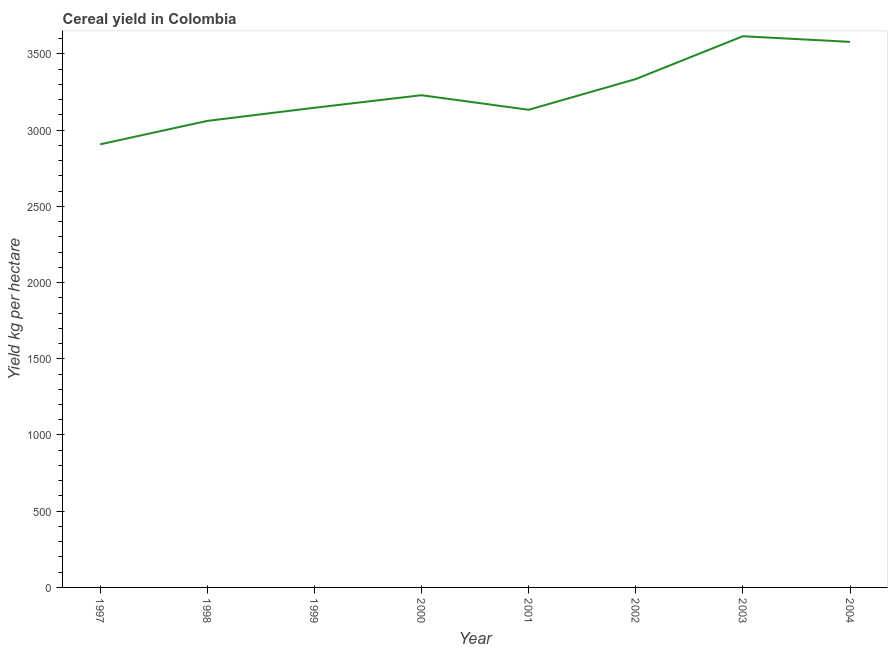What is the cereal yield in 1997?
Give a very brief answer. 2906.72. Across all years, what is the maximum cereal yield?
Your answer should be very brief. 3615.99. Across all years, what is the minimum cereal yield?
Your response must be concise. 2906.72. What is the sum of the cereal yield?
Provide a succinct answer. 2.60e+04. What is the difference between the cereal yield in 2000 and 2003?
Offer a terse response. -386.91. What is the average cereal yield per year?
Your answer should be compact. 3250.8. What is the median cereal yield?
Your response must be concise. 3187.87. In how many years, is the cereal yield greater than 700 kg per hectare?
Ensure brevity in your answer.  8. What is the ratio of the cereal yield in 2002 to that in 2004?
Provide a short and direct response. 0.93. Is the cereal yield in 1998 less than that in 2003?
Offer a very short reply. Yes. Is the difference between the cereal yield in 2000 and 2003 greater than the difference between any two years?
Ensure brevity in your answer.  No. What is the difference between the highest and the second highest cereal yield?
Your answer should be compact. 36.93. What is the difference between the highest and the lowest cereal yield?
Your answer should be compact. 709.27. In how many years, is the cereal yield greater than the average cereal yield taken over all years?
Offer a very short reply. 3. How many years are there in the graph?
Keep it short and to the point. 8. What is the difference between two consecutive major ticks on the Y-axis?
Provide a succinct answer. 500. What is the title of the graph?
Your answer should be compact. Cereal yield in Colombia. What is the label or title of the X-axis?
Make the answer very short. Year. What is the label or title of the Y-axis?
Give a very brief answer. Yield kg per hectare. What is the Yield kg per hectare of 1997?
Ensure brevity in your answer.  2906.72. What is the Yield kg per hectare in 1998?
Ensure brevity in your answer.  3060.45. What is the Yield kg per hectare of 1999?
Your response must be concise. 3146.66. What is the Yield kg per hectare of 2000?
Provide a short and direct response. 3229.09. What is the Yield kg per hectare of 2001?
Your answer should be compact. 3133.53. What is the Yield kg per hectare of 2002?
Your answer should be very brief. 3334.92. What is the Yield kg per hectare of 2003?
Give a very brief answer. 3615.99. What is the Yield kg per hectare in 2004?
Your response must be concise. 3579.07. What is the difference between the Yield kg per hectare in 1997 and 1998?
Provide a succinct answer. -153.72. What is the difference between the Yield kg per hectare in 1997 and 1999?
Provide a succinct answer. -239.94. What is the difference between the Yield kg per hectare in 1997 and 2000?
Provide a short and direct response. -322.36. What is the difference between the Yield kg per hectare in 1997 and 2001?
Provide a succinct answer. -226.81. What is the difference between the Yield kg per hectare in 1997 and 2002?
Keep it short and to the point. -428.19. What is the difference between the Yield kg per hectare in 1997 and 2003?
Provide a succinct answer. -709.27. What is the difference between the Yield kg per hectare in 1997 and 2004?
Keep it short and to the point. -672.34. What is the difference between the Yield kg per hectare in 1998 and 1999?
Your response must be concise. -86.22. What is the difference between the Yield kg per hectare in 1998 and 2000?
Give a very brief answer. -168.64. What is the difference between the Yield kg per hectare in 1998 and 2001?
Ensure brevity in your answer.  -73.09. What is the difference between the Yield kg per hectare in 1998 and 2002?
Your response must be concise. -274.47. What is the difference between the Yield kg per hectare in 1998 and 2003?
Your answer should be compact. -555.55. What is the difference between the Yield kg per hectare in 1998 and 2004?
Offer a very short reply. -518.62. What is the difference between the Yield kg per hectare in 1999 and 2000?
Your response must be concise. -82.42. What is the difference between the Yield kg per hectare in 1999 and 2001?
Give a very brief answer. 13.13. What is the difference between the Yield kg per hectare in 1999 and 2002?
Give a very brief answer. -188.25. What is the difference between the Yield kg per hectare in 1999 and 2003?
Your answer should be compact. -469.33. What is the difference between the Yield kg per hectare in 1999 and 2004?
Provide a short and direct response. -432.4. What is the difference between the Yield kg per hectare in 2000 and 2001?
Keep it short and to the point. 95.56. What is the difference between the Yield kg per hectare in 2000 and 2002?
Give a very brief answer. -105.83. What is the difference between the Yield kg per hectare in 2000 and 2003?
Offer a terse response. -386.91. What is the difference between the Yield kg per hectare in 2000 and 2004?
Make the answer very short. -349.98. What is the difference between the Yield kg per hectare in 2001 and 2002?
Keep it short and to the point. -201.39. What is the difference between the Yield kg per hectare in 2001 and 2003?
Give a very brief answer. -482.46. What is the difference between the Yield kg per hectare in 2001 and 2004?
Ensure brevity in your answer.  -445.54. What is the difference between the Yield kg per hectare in 2002 and 2003?
Provide a short and direct response. -281.08. What is the difference between the Yield kg per hectare in 2002 and 2004?
Ensure brevity in your answer.  -244.15. What is the difference between the Yield kg per hectare in 2003 and 2004?
Your answer should be very brief. 36.93. What is the ratio of the Yield kg per hectare in 1997 to that in 1998?
Provide a short and direct response. 0.95. What is the ratio of the Yield kg per hectare in 1997 to that in 1999?
Your answer should be compact. 0.92. What is the ratio of the Yield kg per hectare in 1997 to that in 2001?
Provide a short and direct response. 0.93. What is the ratio of the Yield kg per hectare in 1997 to that in 2002?
Your response must be concise. 0.87. What is the ratio of the Yield kg per hectare in 1997 to that in 2003?
Your answer should be very brief. 0.8. What is the ratio of the Yield kg per hectare in 1997 to that in 2004?
Keep it short and to the point. 0.81. What is the ratio of the Yield kg per hectare in 1998 to that in 2000?
Keep it short and to the point. 0.95. What is the ratio of the Yield kg per hectare in 1998 to that in 2002?
Offer a terse response. 0.92. What is the ratio of the Yield kg per hectare in 1998 to that in 2003?
Offer a very short reply. 0.85. What is the ratio of the Yield kg per hectare in 1998 to that in 2004?
Your answer should be very brief. 0.85. What is the ratio of the Yield kg per hectare in 1999 to that in 2000?
Your response must be concise. 0.97. What is the ratio of the Yield kg per hectare in 1999 to that in 2002?
Keep it short and to the point. 0.94. What is the ratio of the Yield kg per hectare in 1999 to that in 2003?
Your answer should be compact. 0.87. What is the ratio of the Yield kg per hectare in 1999 to that in 2004?
Ensure brevity in your answer.  0.88. What is the ratio of the Yield kg per hectare in 2000 to that in 2001?
Your response must be concise. 1.03. What is the ratio of the Yield kg per hectare in 2000 to that in 2002?
Offer a very short reply. 0.97. What is the ratio of the Yield kg per hectare in 2000 to that in 2003?
Offer a terse response. 0.89. What is the ratio of the Yield kg per hectare in 2000 to that in 2004?
Offer a terse response. 0.9. What is the ratio of the Yield kg per hectare in 2001 to that in 2002?
Offer a terse response. 0.94. What is the ratio of the Yield kg per hectare in 2001 to that in 2003?
Your response must be concise. 0.87. What is the ratio of the Yield kg per hectare in 2001 to that in 2004?
Provide a short and direct response. 0.88. What is the ratio of the Yield kg per hectare in 2002 to that in 2003?
Offer a very short reply. 0.92. What is the ratio of the Yield kg per hectare in 2002 to that in 2004?
Provide a succinct answer. 0.93. What is the ratio of the Yield kg per hectare in 2003 to that in 2004?
Your answer should be compact. 1.01. 